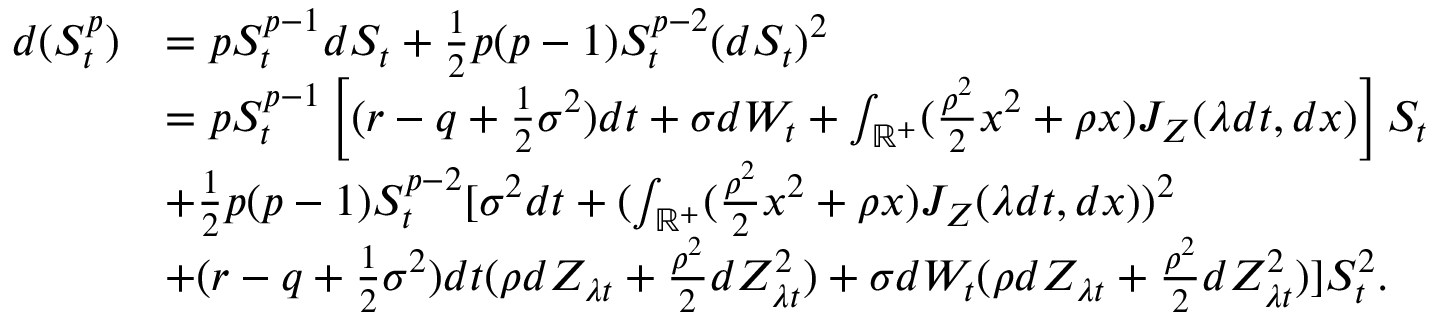Convert formula to latex. <formula><loc_0><loc_0><loc_500><loc_500>\begin{array} { r l } { d ( S _ { t } ^ { p } ) } & { = p S _ { t } ^ { p - 1 } d S _ { t } + \frac { 1 } { 2 } p ( p - 1 ) S _ { t } ^ { p - 2 } ( d S _ { t } ) ^ { 2 } } \\ & { = p S _ { t } ^ { p - 1 } \left [ ( r - q + \frac { 1 } { 2 } \sigma ^ { 2 } ) d t + \sigma d W _ { t } + \int _ { \mathbb { R } ^ { + } } ( \frac { \rho ^ { 2 } } { 2 } x ^ { 2 } + \rho x ) { J } _ { Z } ( \lambda d t , d x ) \right ] S _ { t } } \\ & { + \frac { 1 } { 2 } p ( p - 1 ) S _ { t } ^ { p - 2 } [ \sigma ^ { 2 } d t + ( \int _ { \mathbb { R } ^ { + } } ( \frac { \rho ^ { 2 } } { 2 } x ^ { 2 } + \rho x ) { J } _ { Z } ( \lambda d t , d x ) ) ^ { 2 } } \\ & { + ( r - q + \frac { 1 } { 2 } \sigma ^ { 2 } ) d t ( \rho d Z _ { \lambda t } + \frac { \rho ^ { 2 } } { 2 } d Z _ { \lambda t } ^ { 2 } ) + \sigma d W _ { t } ( \rho d Z _ { \lambda t } + \frac { \rho ^ { 2 } } { 2 } d Z _ { \lambda t } ^ { 2 } ) ] S _ { t } ^ { 2 } . } \end{array}</formula> 